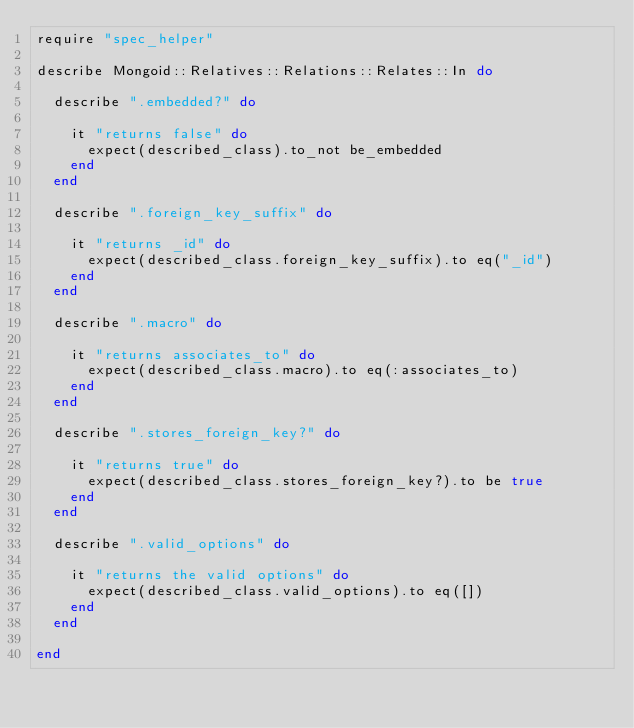Convert code to text. <code><loc_0><loc_0><loc_500><loc_500><_Ruby_>require "spec_helper"

describe Mongoid::Relatives::Relations::Relates::In do

  describe ".embedded?" do

    it "returns false" do
      expect(described_class).to_not be_embedded
    end
  end

  describe ".foreign_key_suffix" do

    it "returns _id" do
      expect(described_class.foreign_key_suffix).to eq("_id")
    end
  end

  describe ".macro" do

    it "returns associates_to" do
      expect(described_class.macro).to eq(:associates_to)
    end
  end

  describe ".stores_foreign_key?" do

    it "returns true" do
      expect(described_class.stores_foreign_key?).to be true
    end
  end

  describe ".valid_options" do

    it "returns the valid options" do
      expect(described_class.valid_options).to eq([])
    end
  end

end
</code> 